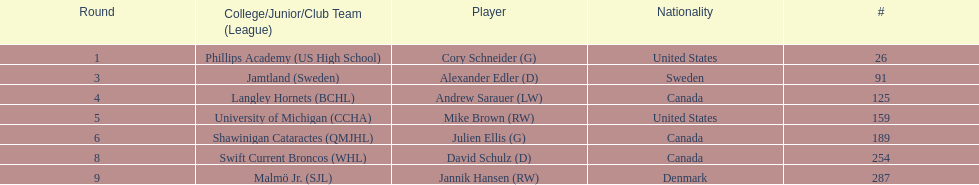Who are the players? Cory Schneider (G), Alexander Edler (D), Andrew Sarauer (LW), Mike Brown (RW), Julien Ellis (G), David Schulz (D), Jannik Hansen (RW). Of those, who is from denmark? Jannik Hansen (RW). 